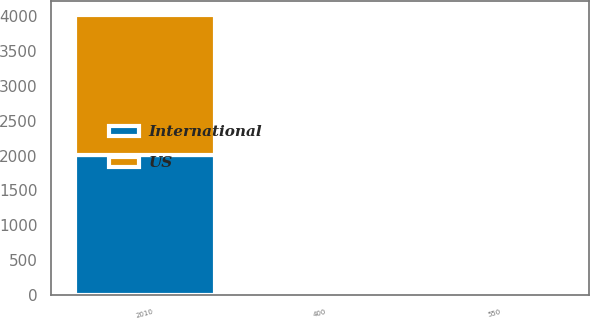Convert chart. <chart><loc_0><loc_0><loc_500><loc_500><stacked_bar_chart><ecel><fcel>2010<fcel>550<fcel>400<nl><fcel>US<fcel>2009<fcel>6<fcel>4<nl><fcel>International<fcel>2010<fcel>5.47<fcel>4.91<nl></chart> 